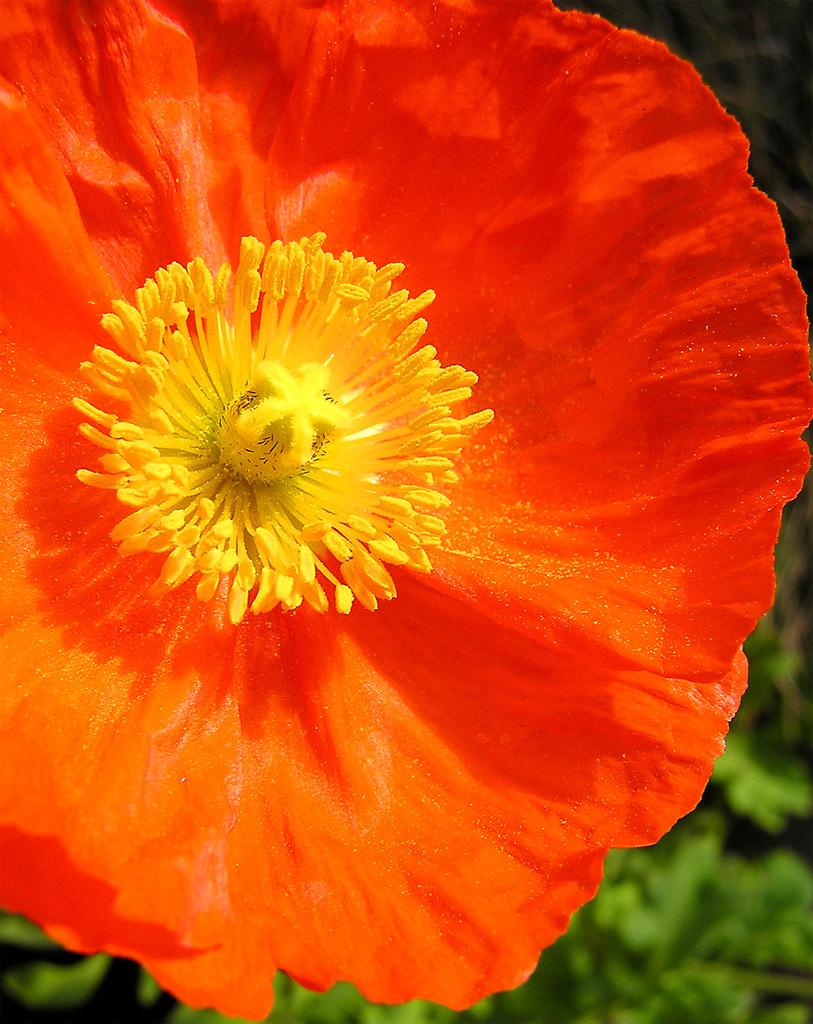What is the main subject of the image? There is a flower in the image. Can you describe the background of the image? The background of the image is blurred. What type of train can be seen passing through the flower in the image? There is no train present in the image; it only features a flower with a blurred background. What kind of wood is used to make the vessel in the image? There is no vessel present in the image, only a flower with a blurred background. 